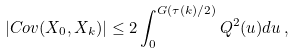<formula> <loc_0><loc_0><loc_500><loc_500>| C o v ( X _ { 0 } , X _ { k } ) | \leq 2 \int _ { 0 } ^ { G ( \tau ( k ) / 2 ) } Q ^ { 2 } ( u ) d u \, ,</formula> 